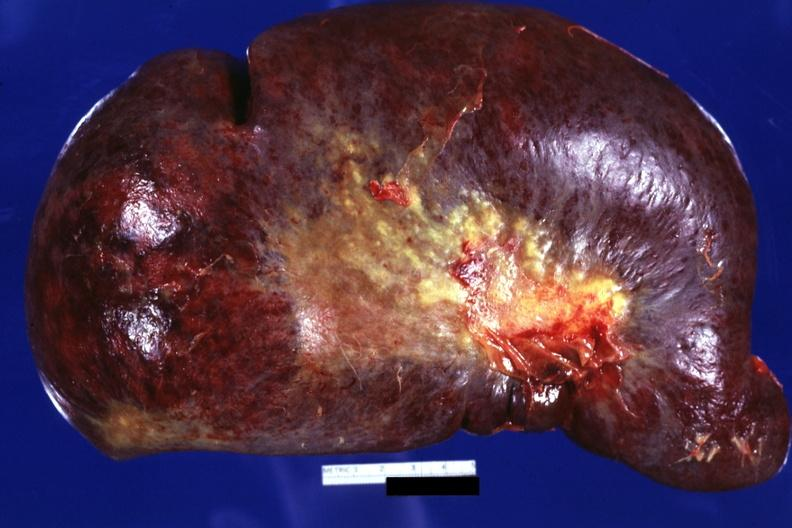does this image show external view huge spleen?
Answer the question using a single word or phrase. Yes 